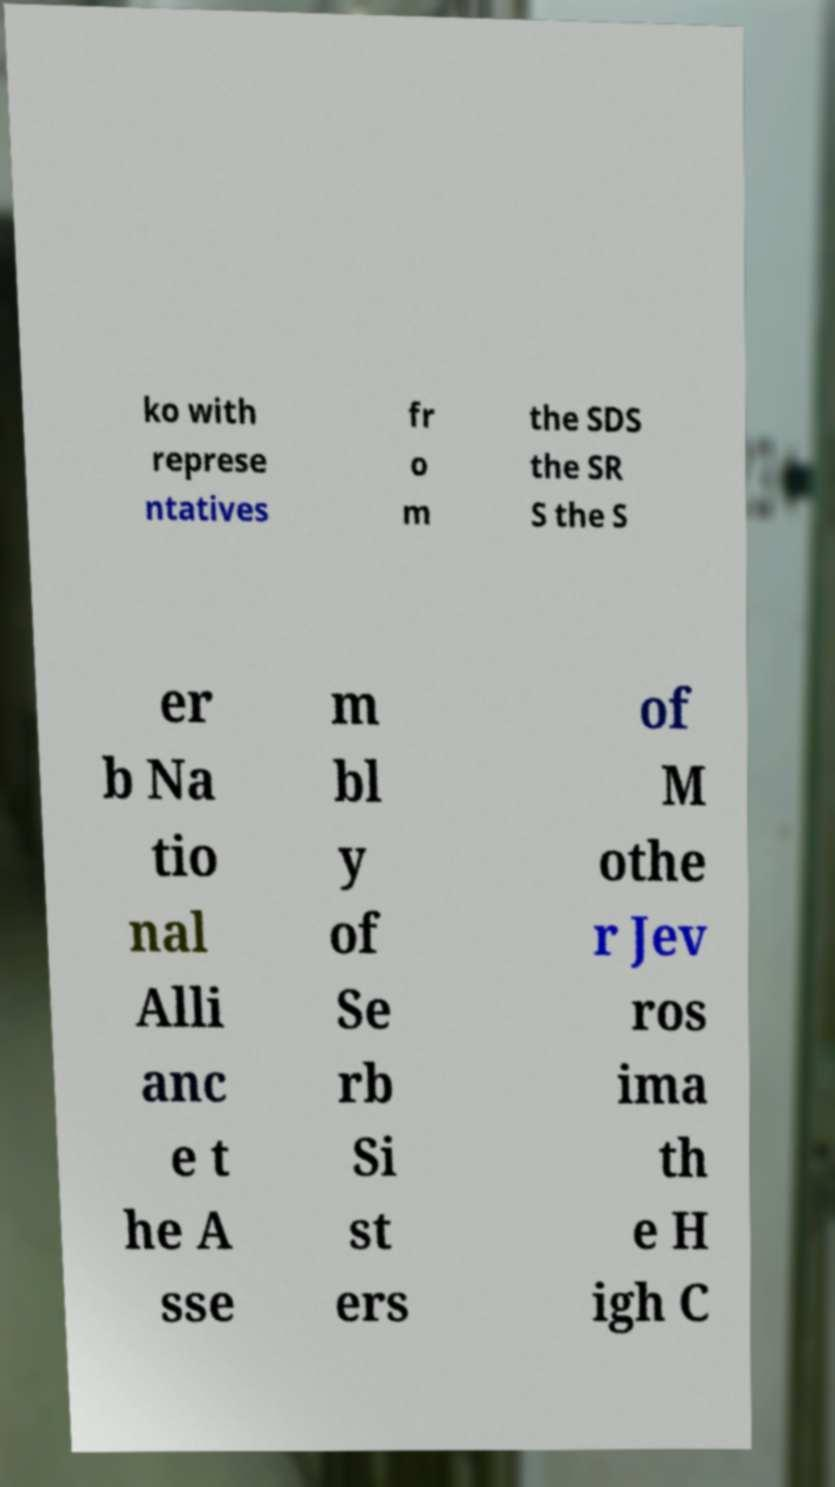Could you assist in decoding the text presented in this image and type it out clearly? ko with represe ntatives fr o m the SDS the SR S the S er b Na tio nal Alli anc e t he A sse m bl y of Se rb Si st ers of M othe r Jev ros ima th e H igh C 